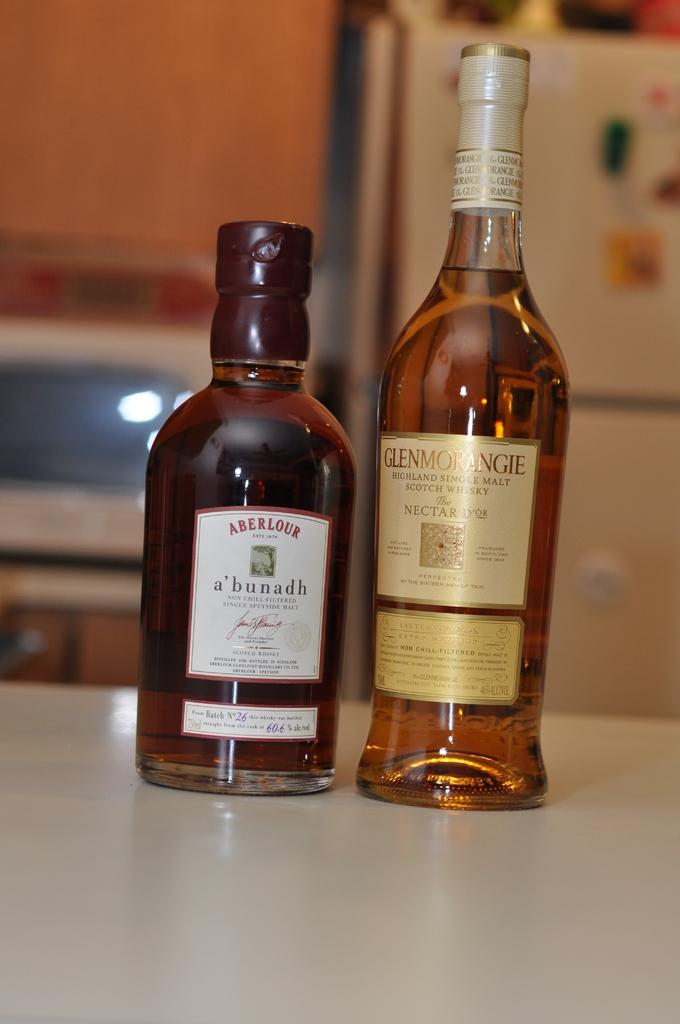<image>
Summarize the visual content of the image. Two bottles next to one another with one that says "Aberlour" on it. 